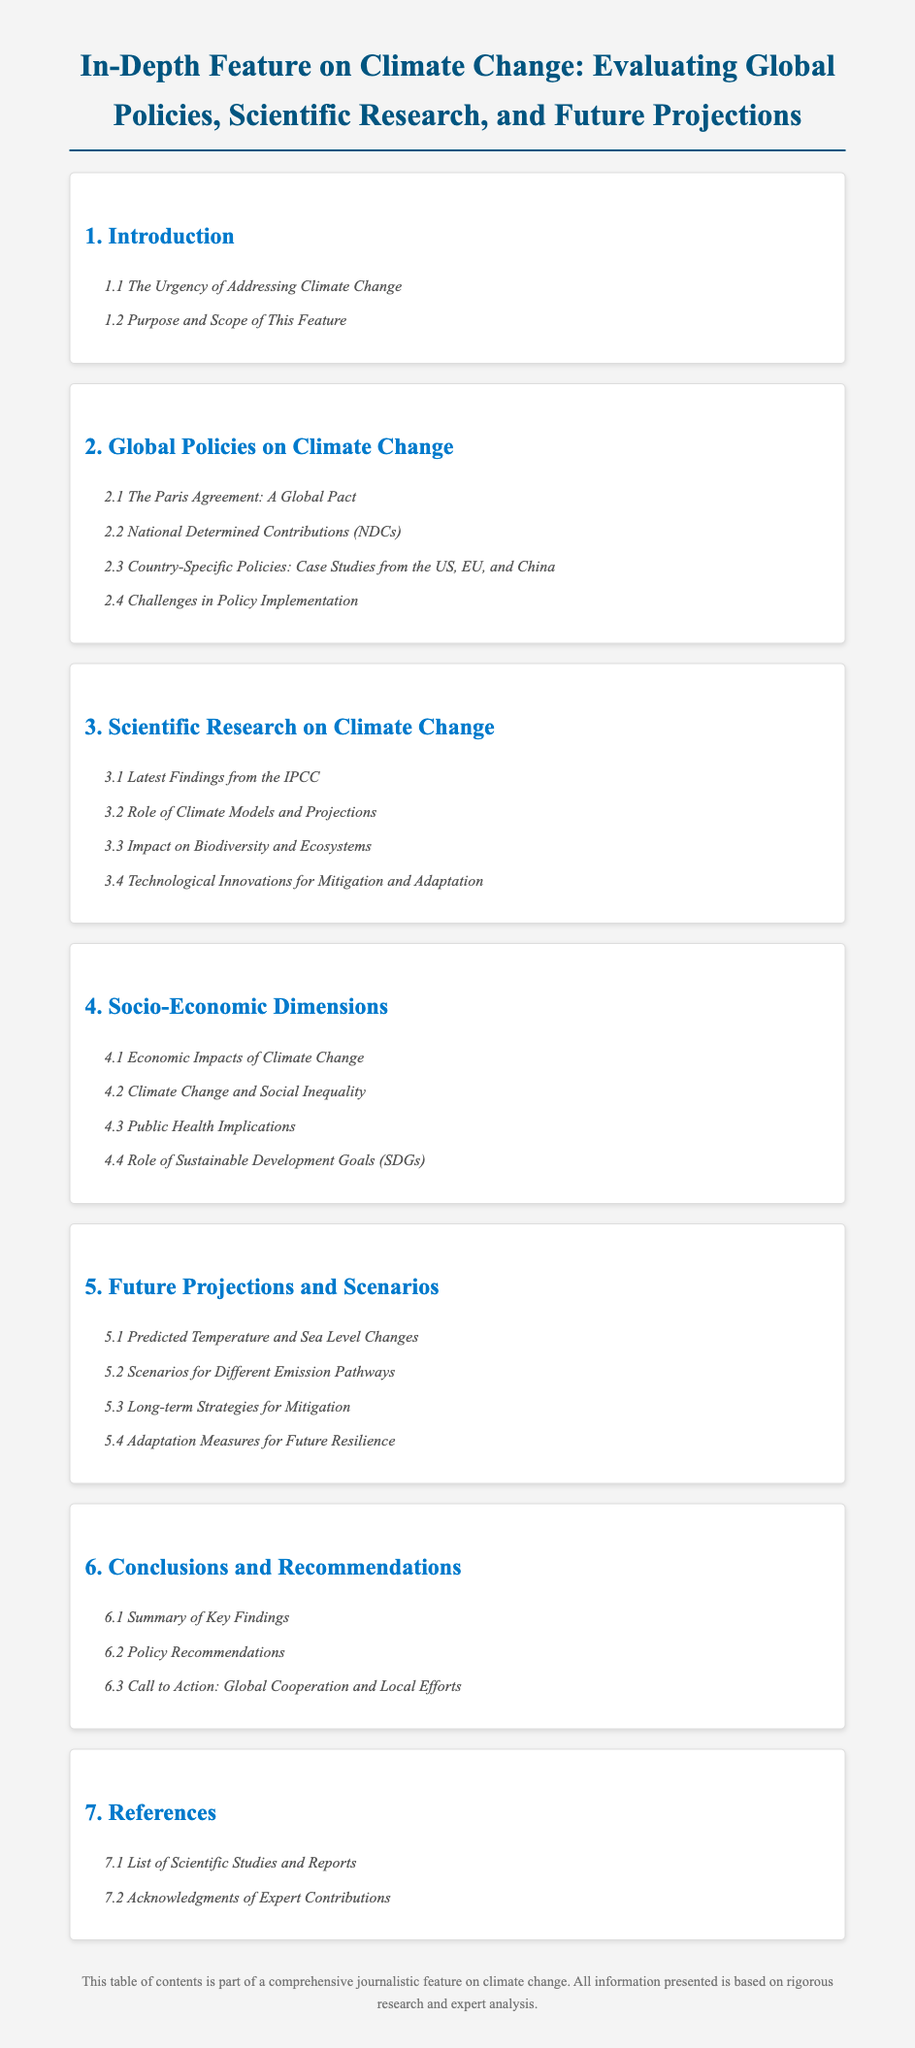what is the title of the document? The title is located at the top of the document and summarizes the overall content.
Answer: In-Depth Feature on Climate Change: Evaluating Global Policies, Scientific Research, and Future Projections how many main sections are in the document? The main sections are clearly numbered in the table of contents, with each section representing a different aspect of climate change.
Answer: 7 what is discussed in subsection 2.1? Subsection 2.1 is listed under the Global Policies on Climate Change section and indicates a specific topic related to global agreements.
Answer: The Paris Agreement: A Global Pact what is the focus of section 4? Section 4 covers a broad area of concern regarding climate change and its impact on society and economies.
Answer: Socio-Economic Dimensions which section addresses adaptation measures? Adaptation measures are specifically mentioned in a section that discusses future actions based on climate projections.
Answer: Section 5: Future Projections and Scenarios what is the primary purpose of this feature? The purpose is outlined in the introduction, providing insight into the intention behind the document.
Answer: Purpose and Scope of This Feature who are acknowledged in the references section? The references section includes contributions from various experts in the field of climate change.
Answer: Expert Contributions 